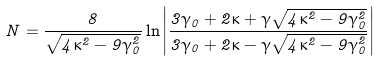<formula> <loc_0><loc_0><loc_500><loc_500>N = \frac { 8 } { \sqrt { 4 \kappa ^ { 2 } - 9 \gamma _ { 0 } ^ { 2 } } } \ln \left | \frac { 3 \gamma _ { 0 } + 2 \kappa + \gamma \sqrt { 4 \kappa ^ { 2 } - 9 \gamma _ { 0 } ^ { 2 } } } { 3 \gamma _ { 0 } + 2 \kappa - \gamma \sqrt { 4 \kappa ^ { 2 } - 9 \gamma _ { 0 } ^ { 2 } } } \right |</formula> 